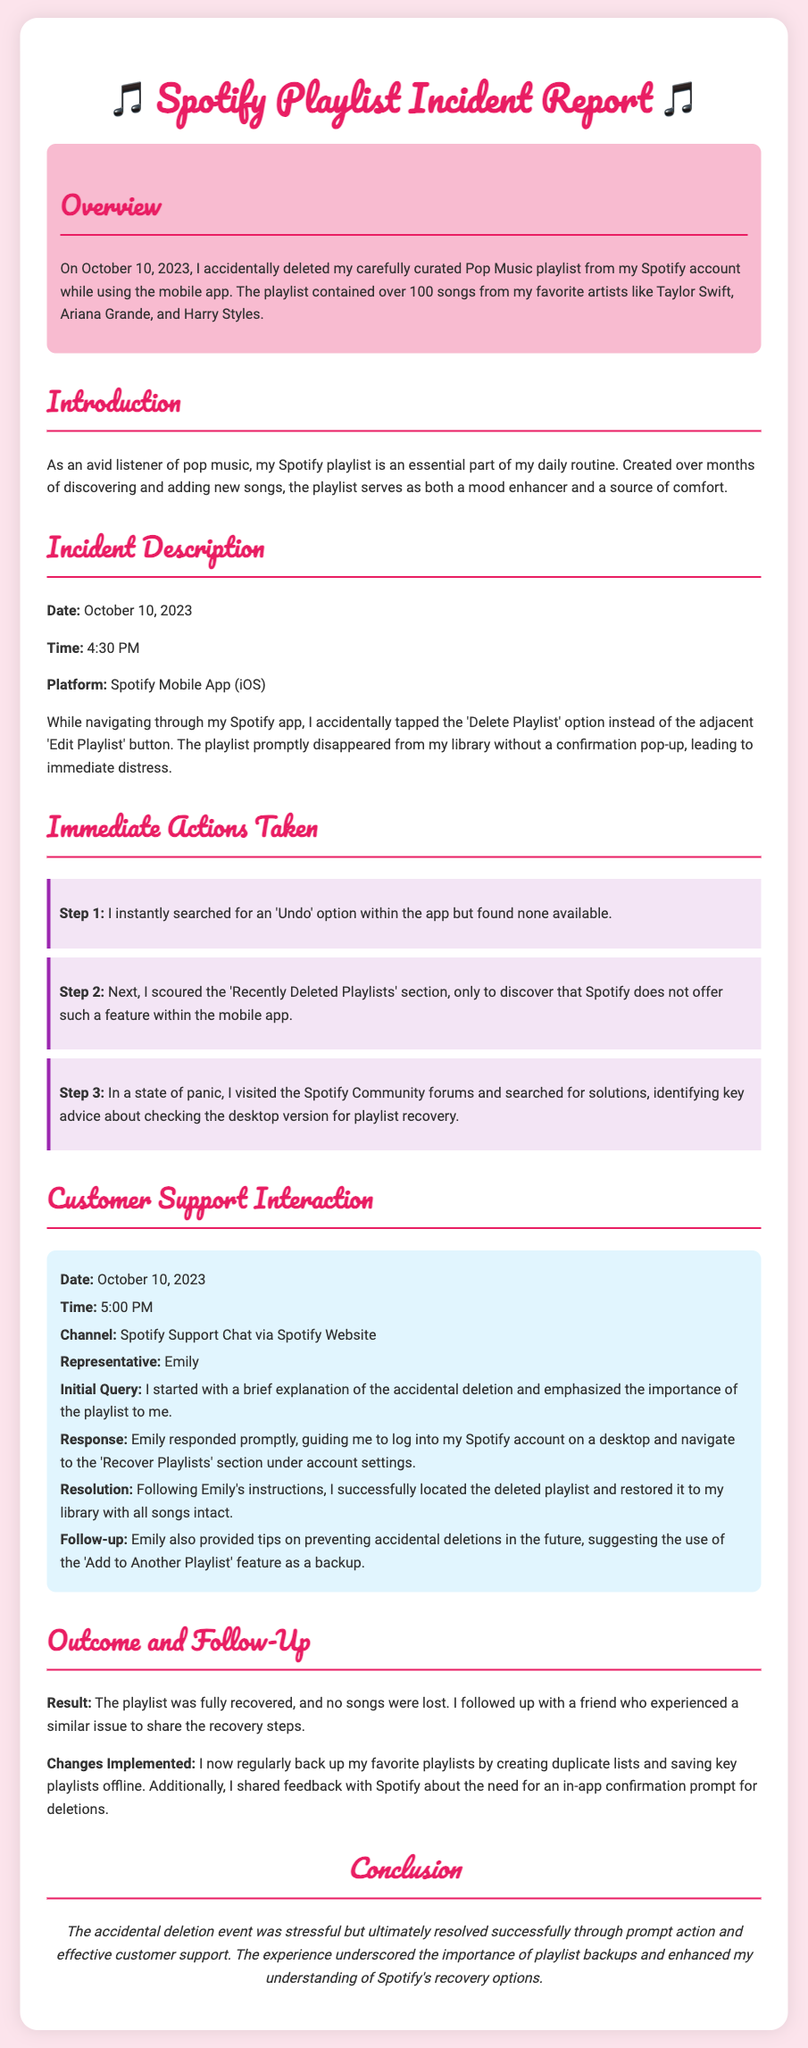What was deleted? The document states that the playlist deleted was a Pop Music playlist from Spotify.
Answer: Pop Music playlist On what date did the incident occur? The report specifies the date of the incident as October 10, 2023.
Answer: October 10, 2023 Who was the customer support representative? The representative mentioned in the support interaction is named Emily.
Answer: Emily What platform was used for the incident? The platform indicated in the incident description is the Spotify Mobile App (iOS).
Answer: Spotify Mobile App (iOS) What time did the deletion happen? The document notes that the deletion occurred at 4:30 PM.
Answer: 4:30 PM What step involved checking the desktop version? The third step mentioned describes visiting the Spotify Community forums for recovery advice, particularly regarding the desktop version.
Answer: Step 3 What was the outcome of the recovery process? The report concludes that the playlist was fully recovered with no songs lost.
Answer: Fully recovered, no songs lost What feature is suggested to prevent accidental deletions? The document mentions the use of the 'Add to Another Playlist' feature as a backup.
Answer: 'Add to Another Playlist' feature What emotional state did the individual experience after deletion? The report describes the emotional state as immediate distress following the accidental deletion.
Answer: Immediate distress 